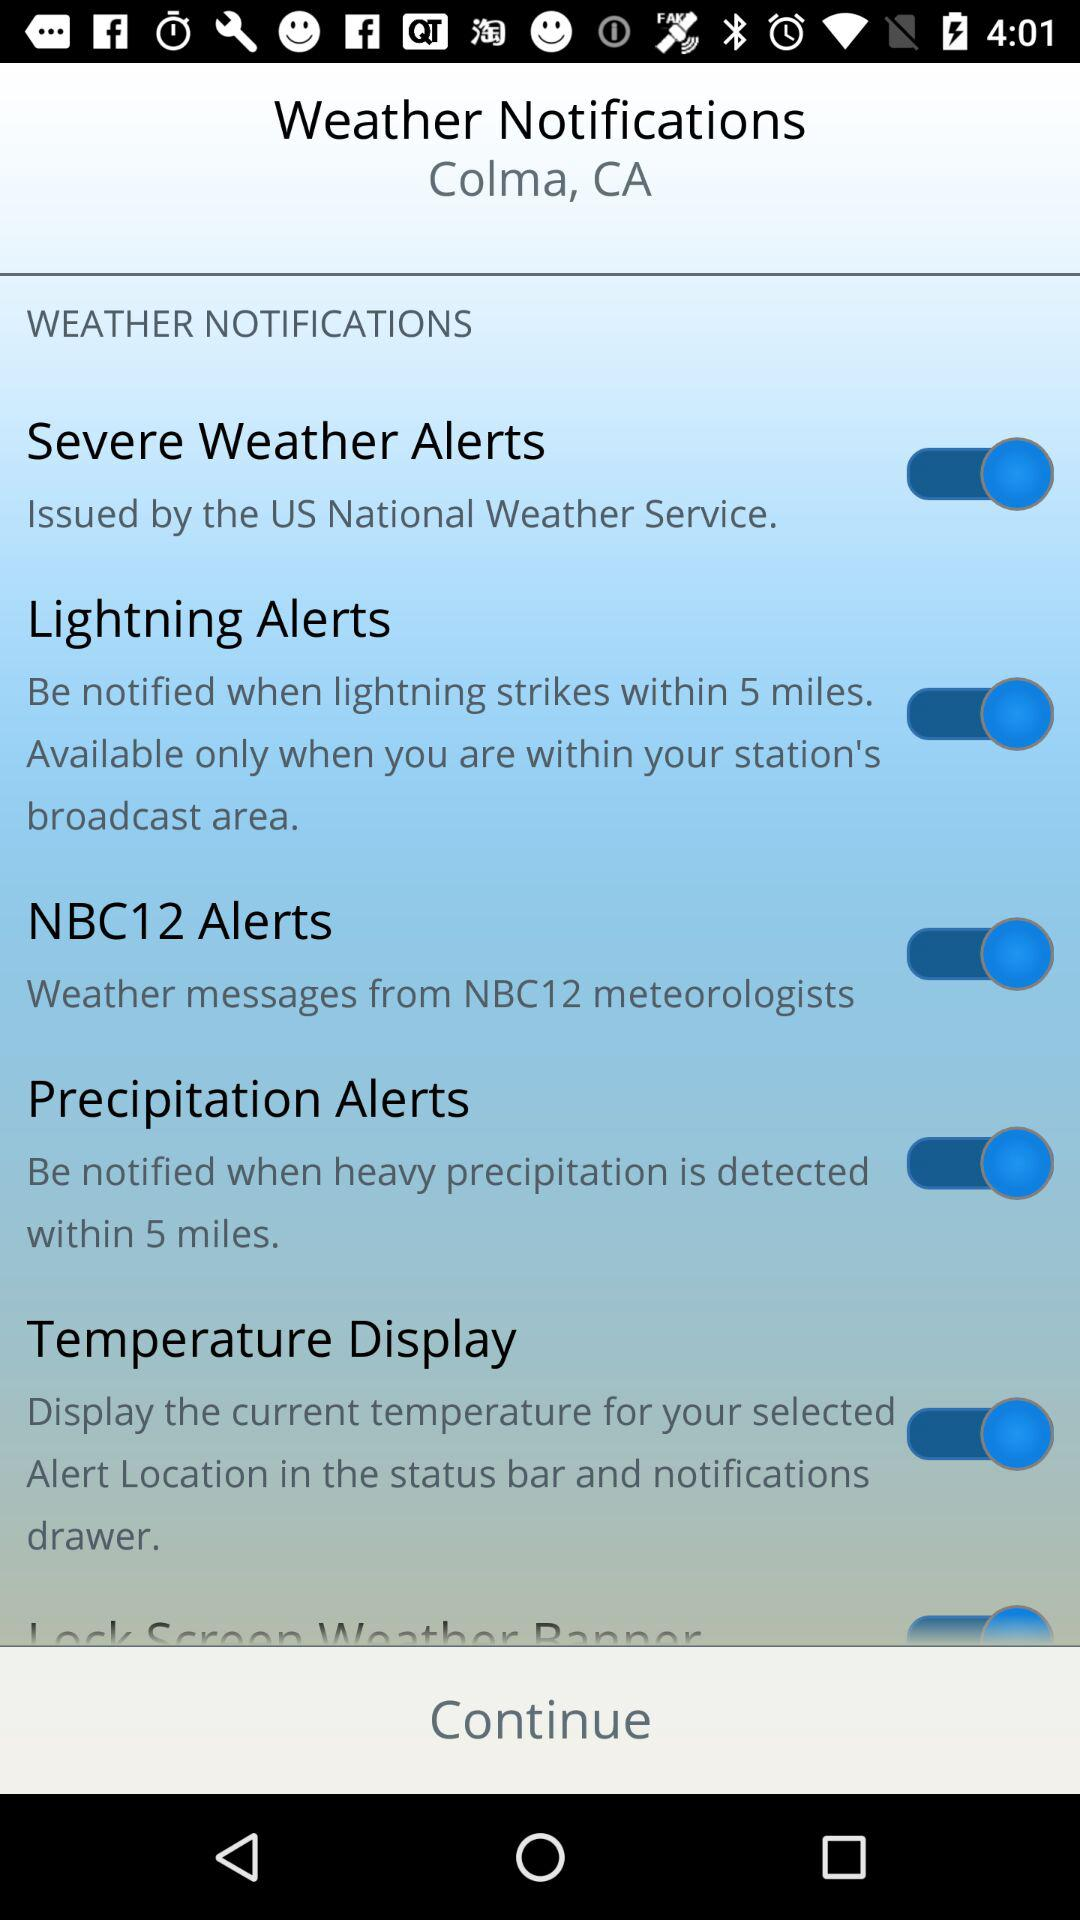What is the location for "Weather Notifications"? The location is Colma, CA. 